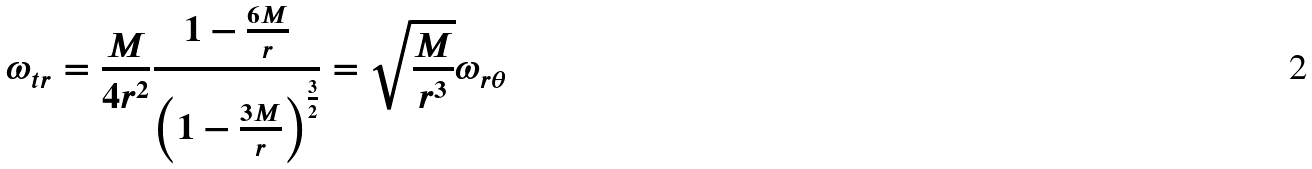Convert formula to latex. <formula><loc_0><loc_0><loc_500><loc_500>\omega _ { t r } = \frac { M } { 4 r ^ { 2 } } \frac { 1 - \frac { 6 M } { r } } { \left ( 1 - \frac { 3 M } { r } \right ) ^ { \frac { 3 } { 2 } } } = \sqrt { \frac { M } { r ^ { 3 } } } \omega _ { r \theta }</formula> 